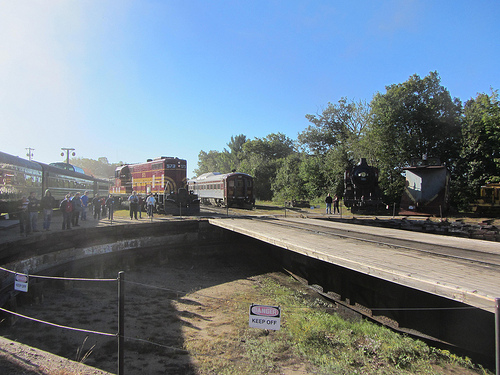Are there either cars or trains that are red? Yes, there are red trains visible in the image. 